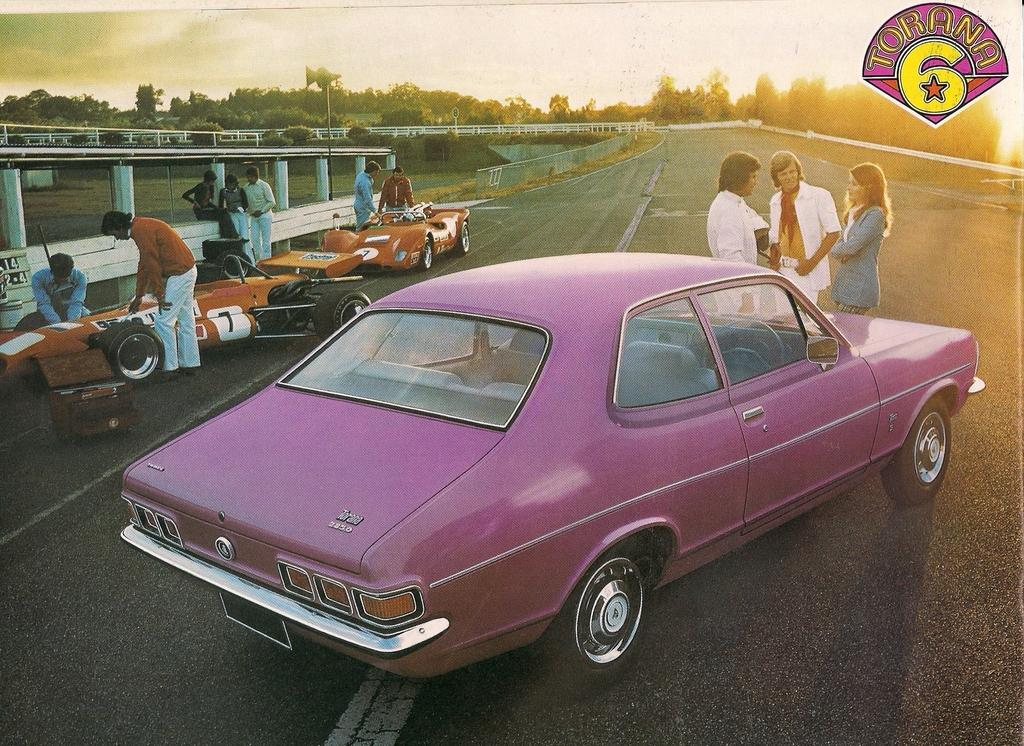What can be seen in the image besides the people on the road? There are vehicles in the image. What is visible in the background of the image? There are trees and the sky visible in the background of the image. Can you describe the logo in the top right corner of the image? Unfortunately, the facts provided do not give any information about the logo, so it cannot be described. What month is it in the image? The facts provided do not give any information about the month, so it cannot be determined. Can you tell me how many giraffes are present in the image? There are no giraffes present in the image. 